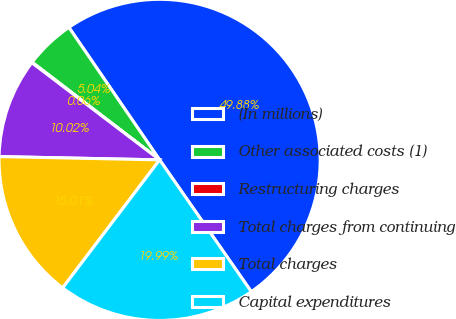<chart> <loc_0><loc_0><loc_500><loc_500><pie_chart><fcel>(In millions)<fcel>Other associated costs (1)<fcel>Restructuring charges<fcel>Total charges from continuing<fcel>Total charges<fcel>Capital expenditures<nl><fcel>49.88%<fcel>5.04%<fcel>0.06%<fcel>10.02%<fcel>15.01%<fcel>19.99%<nl></chart> 